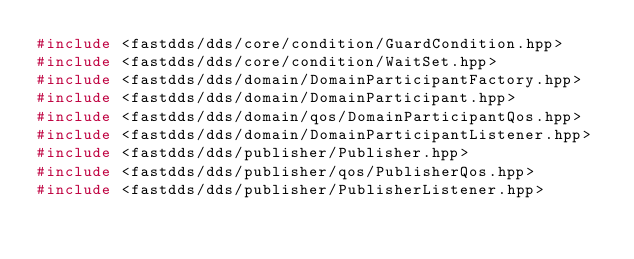<code> <loc_0><loc_0><loc_500><loc_500><_C++_>#include <fastdds/dds/core/condition/GuardCondition.hpp>
#include <fastdds/dds/core/condition/WaitSet.hpp>
#include <fastdds/dds/domain/DomainParticipantFactory.hpp>
#include <fastdds/dds/domain/DomainParticipant.hpp>
#include <fastdds/dds/domain/qos/DomainParticipantQos.hpp>
#include <fastdds/dds/domain/DomainParticipantListener.hpp>
#include <fastdds/dds/publisher/Publisher.hpp>
#include <fastdds/dds/publisher/qos/PublisherQos.hpp>
#include <fastdds/dds/publisher/PublisherListener.hpp></code> 